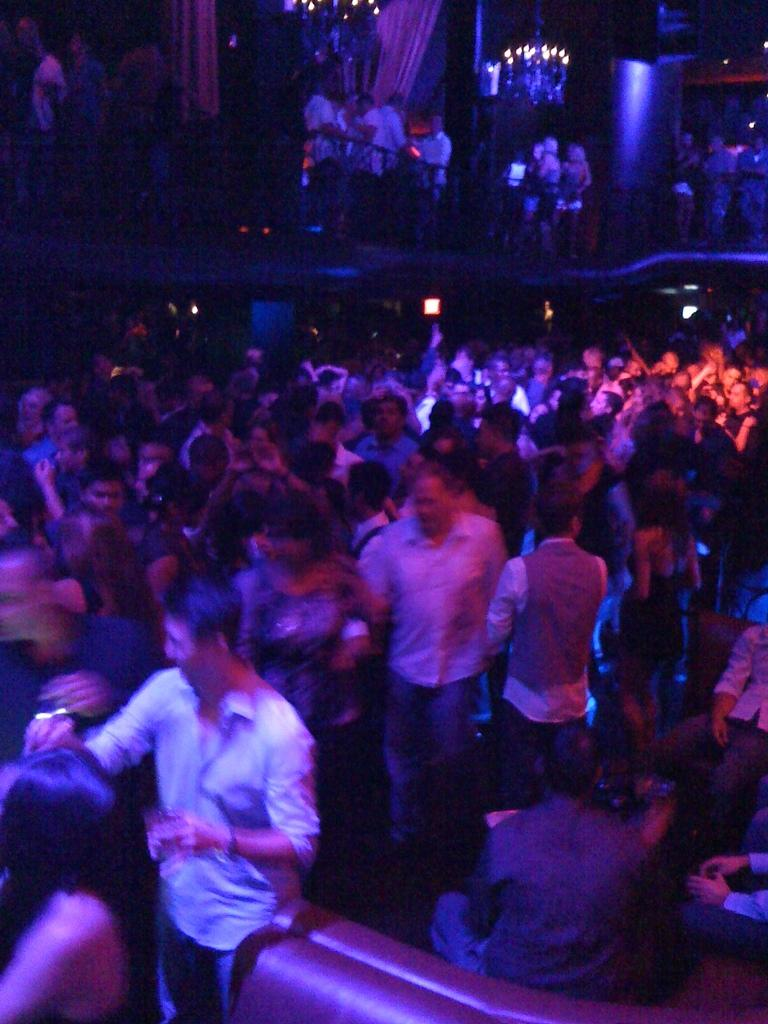How many people are in the image? There is a group of people in the image, but the exact number is not specified. Where are the people located in the image? The group of people is in one place in the image. What type of songs are the people singing in the image? There is no indication in the image that the people are singing songs, so it cannot be determined from the picture. 